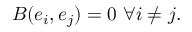<formula> <loc_0><loc_0><loc_500><loc_500>B ( e _ { i } , e _ { j } ) = 0 \ \forall i \neq j .</formula> 